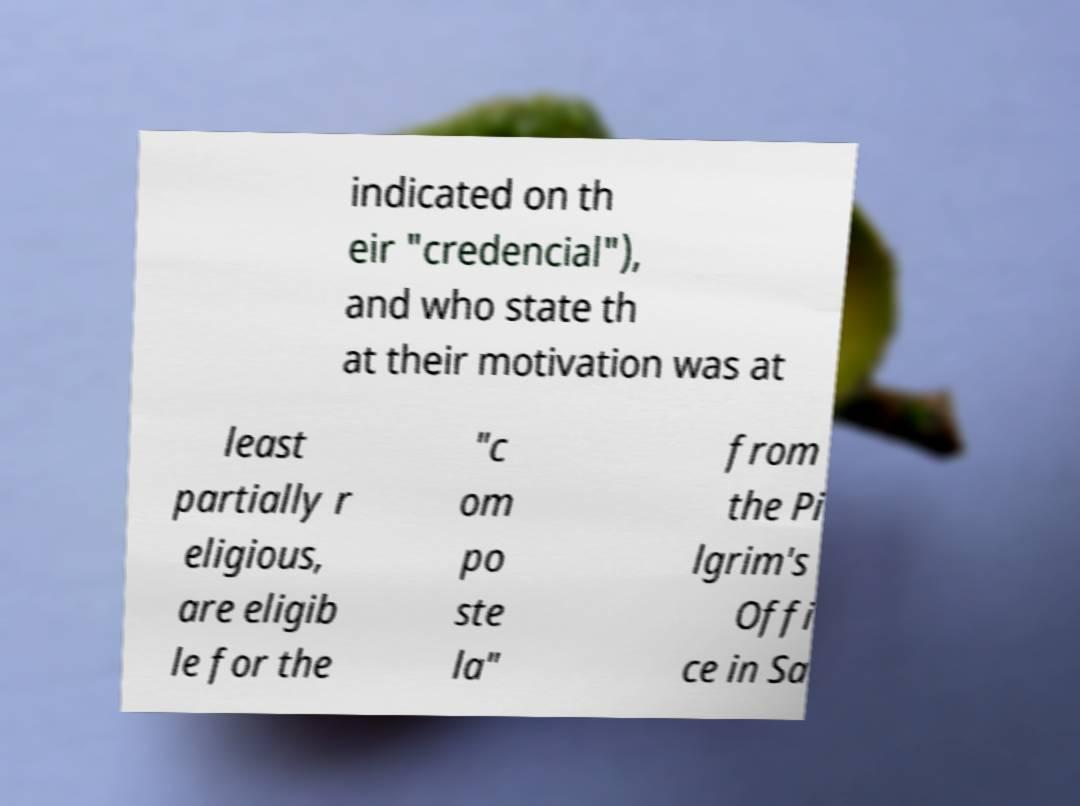Can you accurately transcribe the text from the provided image for me? indicated on th eir "credencial"), and who state th at their motivation was at least partially r eligious, are eligib le for the "c om po ste la" from the Pi lgrim's Offi ce in Sa 